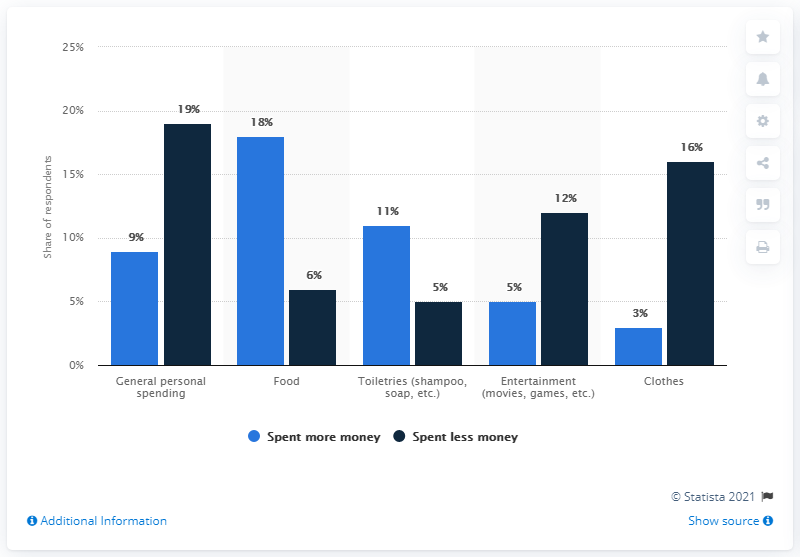Identify some key points in this picture. The light blue bars represent an increase in spending, indicating that more money was spent in that particular category. Of the respondents who have spent more, the total number is 46% 